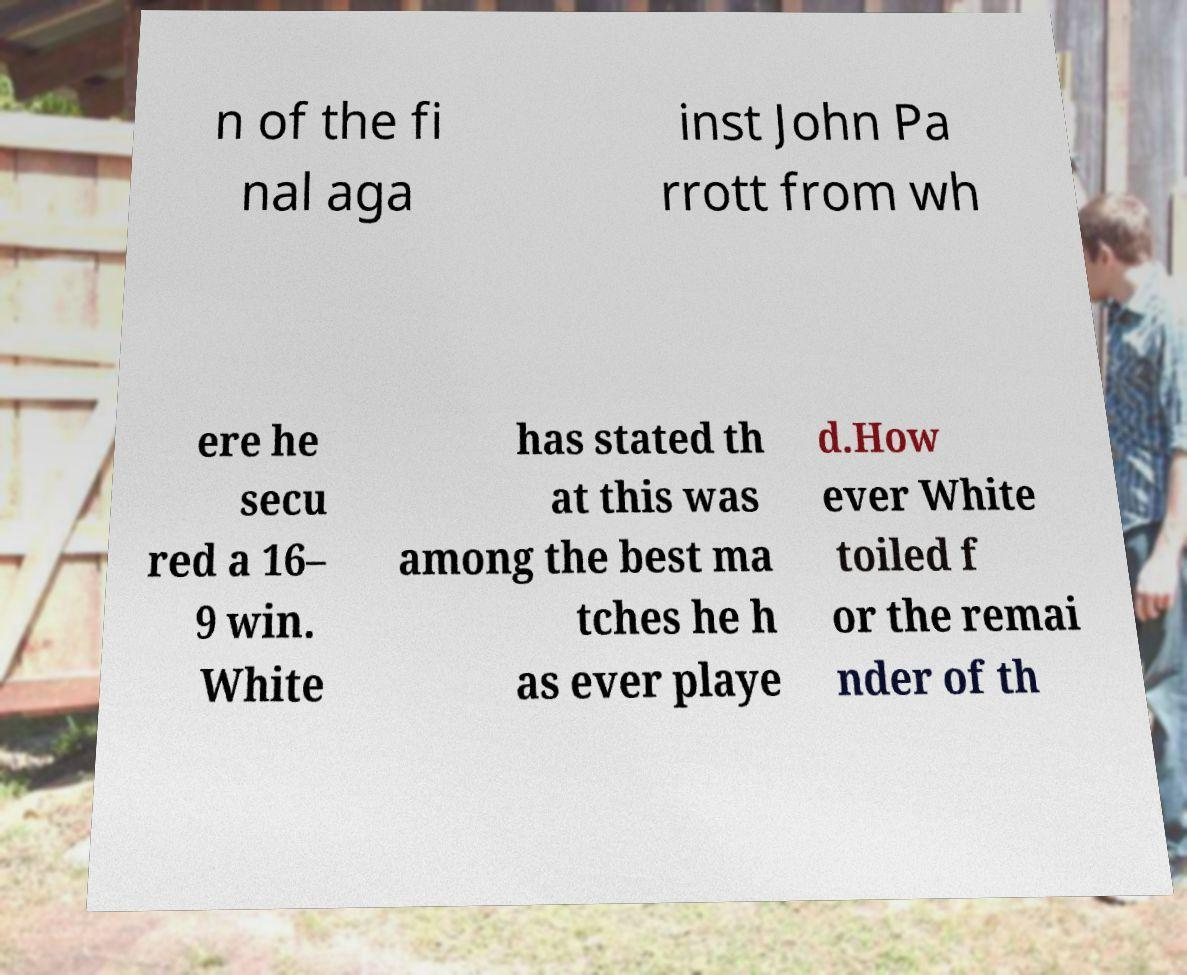Could you assist in decoding the text presented in this image and type it out clearly? n of the fi nal aga inst John Pa rrott from wh ere he secu red a 16– 9 win. White has stated th at this was among the best ma tches he h as ever playe d.How ever White toiled f or the remai nder of th 